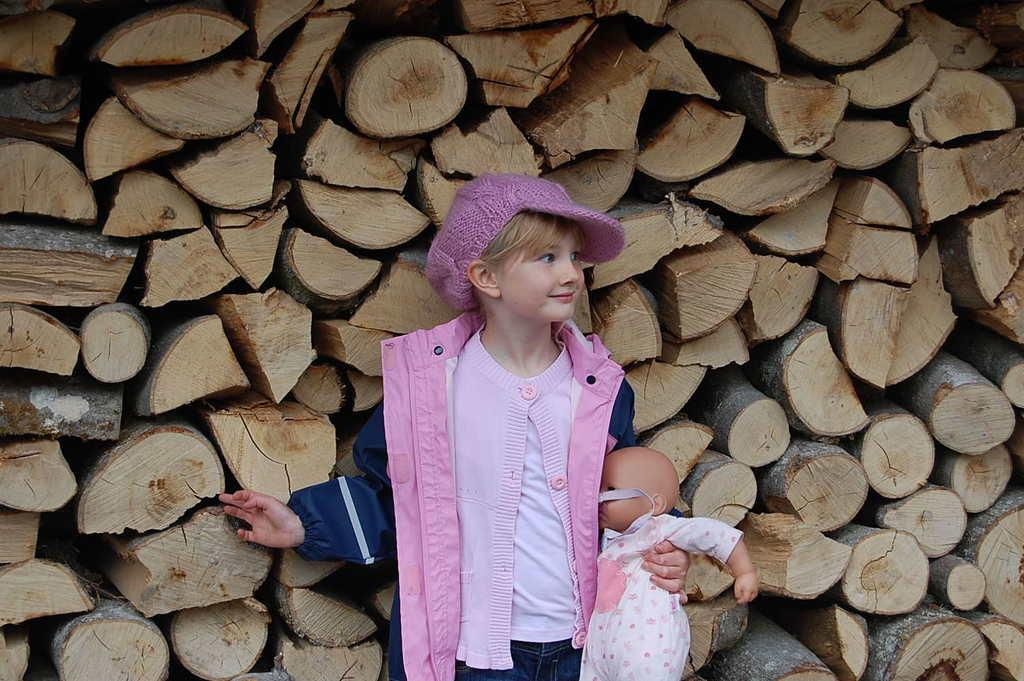Who is in the image? There is a boy in the image. What is the boy doing? The boy is standing. What is the boy holding in his hand? The boy is holding a toy in his hand. What is the boy wearing on his head? The boy is wearing a cap. What can be seen behind the toy in the image? There are wooden logs behind the toy. What type of territory does the boy claim in the image? There is no indication of the boy claiming any territory in the image. 